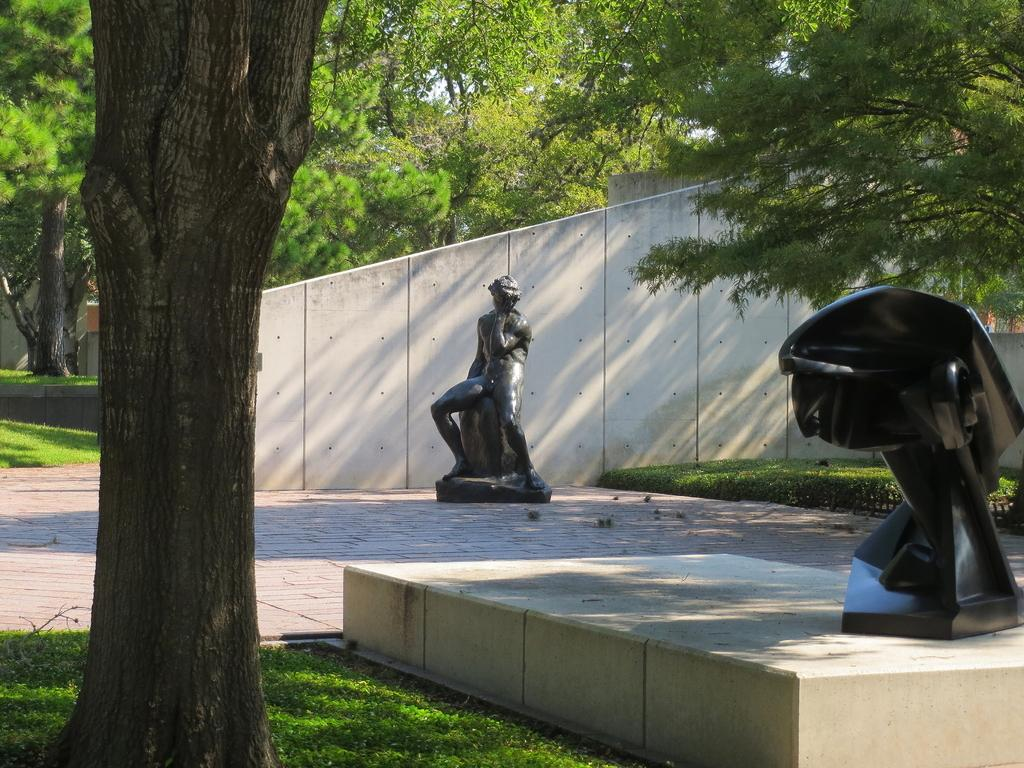What type of objects are the two statues in the image? The two statues in the image are black in color. What can be seen in the background of the image? Trees are visible in the image. What type of barrier is present in the image? There is fencing in the image. How many horses are present in the image? There are no horses visible in the image. What type of sea creature can be seen in the image? There are no sea creatures, such as clams, present in the image. 